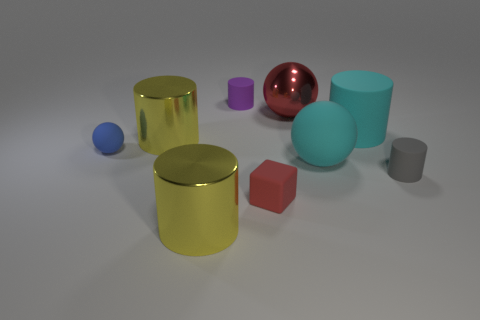Does the ball right of the big red ball have the same size as the yellow cylinder that is in front of the small red rubber cube?
Your answer should be very brief. Yes. There is another sphere that is the same size as the red ball; what is its material?
Your answer should be compact. Rubber. There is a object that is both to the left of the small purple matte cylinder and in front of the tiny gray cylinder; what is its material?
Your answer should be compact. Metal. Are there any small brown rubber balls?
Offer a very short reply. No. Do the rubber block and the small object behind the small sphere have the same color?
Your response must be concise. No. There is a large object that is the same color as the cube; what is it made of?
Provide a short and direct response. Metal. Are there any other things that have the same shape as the purple object?
Ensure brevity in your answer.  Yes. There is a metallic thing on the right side of the small matte cube on the left side of the small cylinder in front of the big cyan cylinder; what shape is it?
Provide a succinct answer. Sphere. There is a small blue thing; what shape is it?
Ensure brevity in your answer.  Sphere. The large matte cylinder that is to the left of the tiny gray cylinder is what color?
Provide a succinct answer. Cyan. 